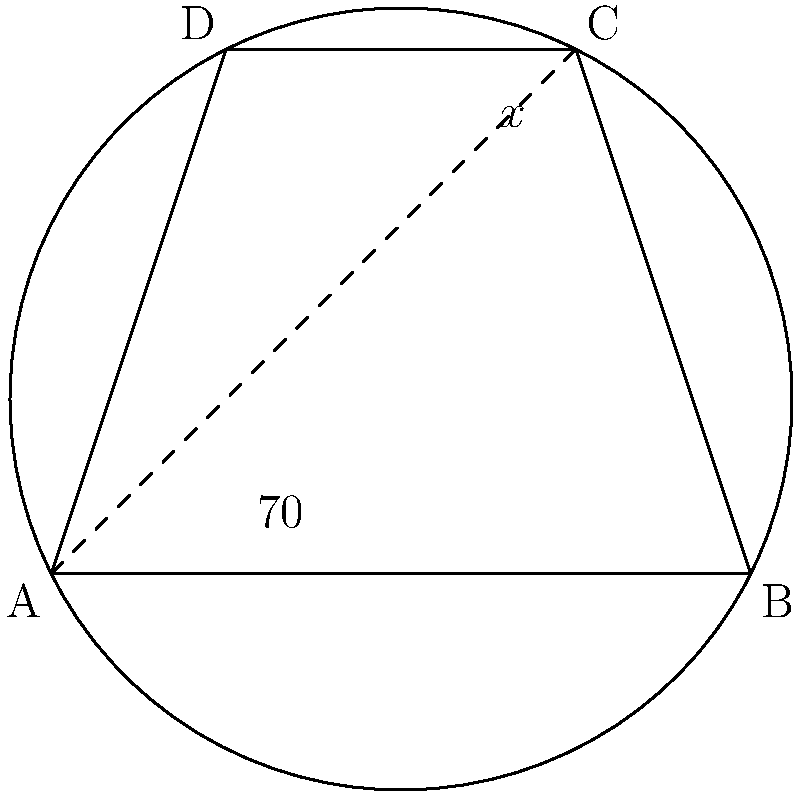In the cyclic quadrilateral ABCD, angle BAD is 70°. What is the measure of angle BCD (denoted as x° in the figure)? To solve this problem, we'll use the properties of cyclic quadrilaterals:

1) In a cyclic quadrilateral, opposite angles are supplementary. This means:
   $$\angle BAD + \angle BCD = 180°$$

2) We know that $\angle BAD = 70°$, so we can substitute this:
   $$70° + x° = 180°$$

3) To find x, we subtract 70° from both sides:
   $$x° = 180° - 70°$$

4) Simplifying:
   $$x° = 110°$$

Therefore, the measure of angle BCD is 110°.

This question demonstrates the application of the cyclic quadrilateral property, which is crucial for understanding circle geometry. It's a practical example of how theoretical knowledge translates into problem-solving skills.
Answer: 110° 